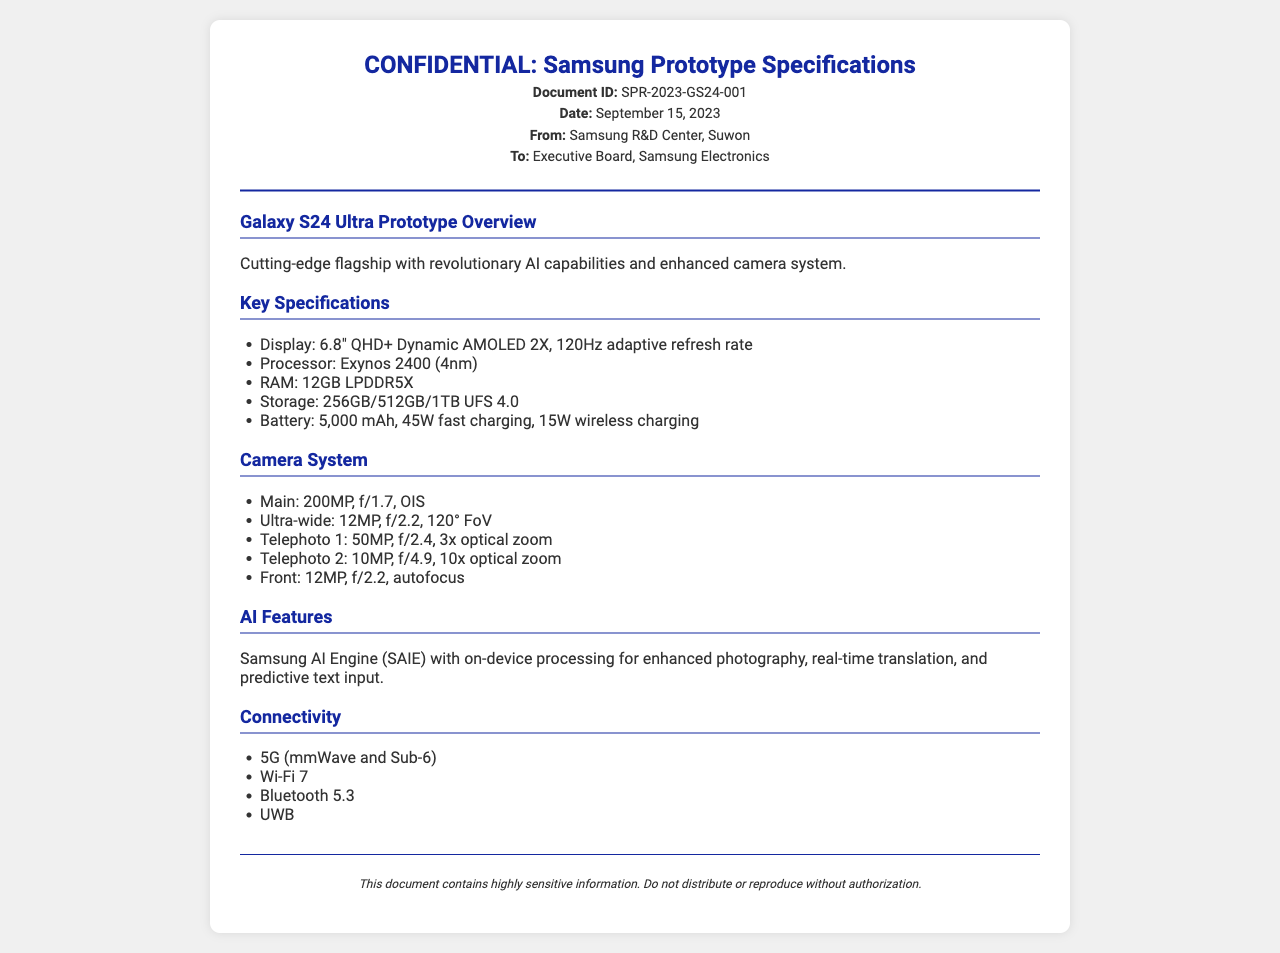What is the document ID? The document ID identifies the report as SPR-2023-GS24-001.
Answer: SPR-2023-GS24-001 What is the release date of the prototype specifications? The release date specified in the document is September 15, 2023.
Answer: September 15, 2023 What is the main camera megapixel count? The main camera is listed as having a 200MP resolution.
Answer: 200MP What is the processor used in the Galaxy S24 Ultra? The document states the processor is the Exynos 2400 (4nm).
Answer: Exynos 2400 (4nm) What is the battery capacity of the prototype? The battery capacity mentioned is 5,000 mAh.
Answer: 5,000 mAh How many optical zoom levels are offered by telephoto lenses? The document lists a total of two telephoto lenses with different optical zoom levels.
Answer: Two What type of Wi-Fi is supported by the device? The device supports Wi-Fi 7 as indicated in the connectivity section.
Answer: Wi-Fi 7 Which organization is the sender of this fax? The sender of the fax is the Samsung R&D Center located in Suwon.
Answer: Samsung R&D Center, Suwon What is the focus of the AI features? The AI features are focused on enhanced photography and real-time translation.
Answer: Enhanced photography and real-time translation 